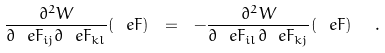<formula> <loc_0><loc_0><loc_500><loc_500>\frac { \partial ^ { 2 } W } { \partial \ e F _ { i j } \partial \ e F _ { k l } } ( \ e F ) \ = \ - \frac { \partial ^ { 2 } W } { \partial \ e F _ { i l } \partial \ e F _ { k j } } ( \ e F ) \ \ .</formula> 